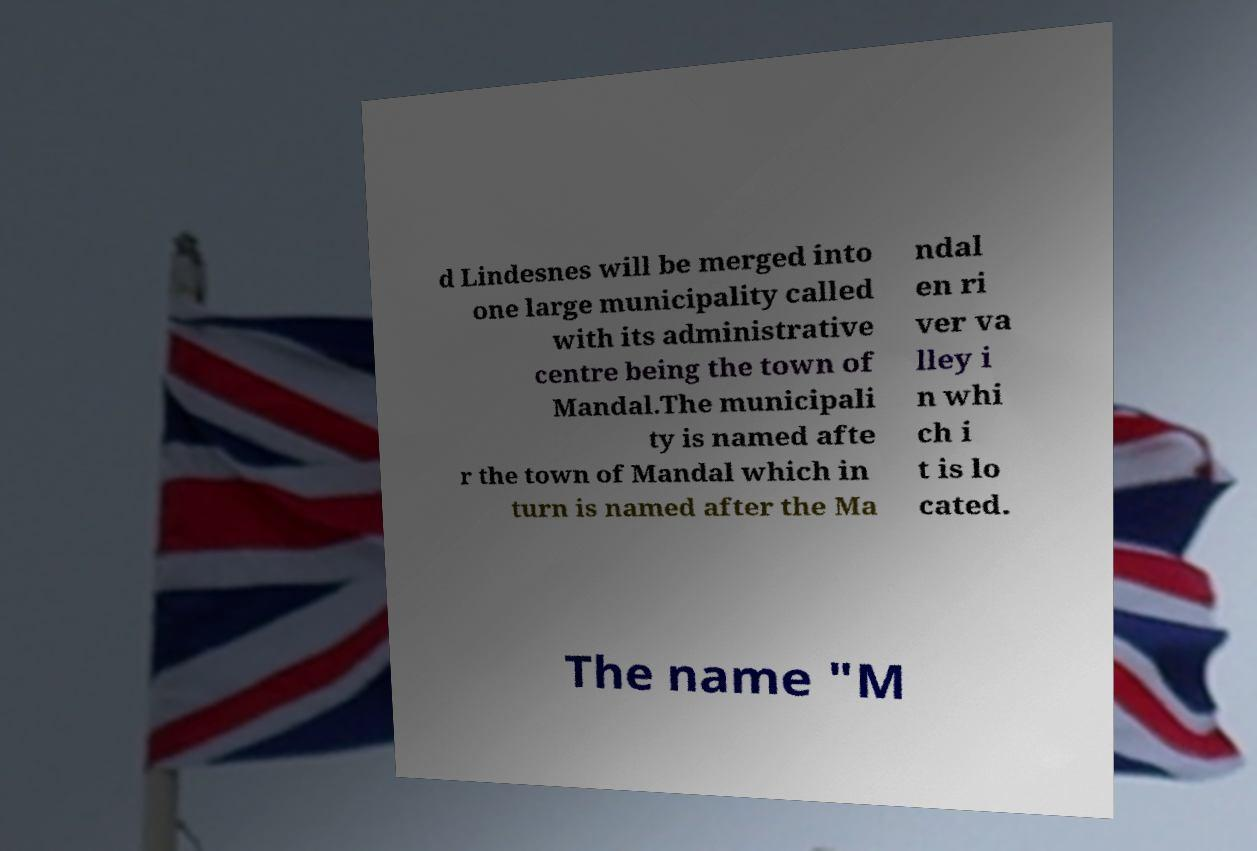Can you accurately transcribe the text from the provided image for me? d Lindesnes will be merged into one large municipality called with its administrative centre being the town of Mandal.The municipali ty is named afte r the town of Mandal which in turn is named after the Ma ndal en ri ver va lley i n whi ch i t is lo cated. The name "M 